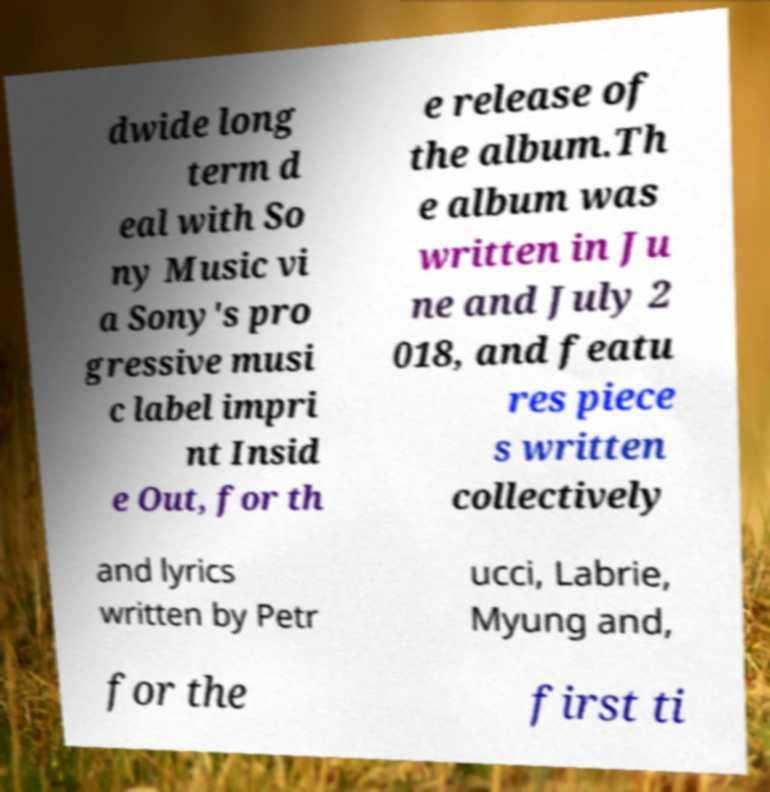Please read and relay the text visible in this image. What does it say? dwide long term d eal with So ny Music vi a Sony's pro gressive musi c label impri nt Insid e Out, for th e release of the album.Th e album was written in Ju ne and July 2 018, and featu res piece s written collectively and lyrics written by Petr ucci, Labrie, Myung and, for the first ti 